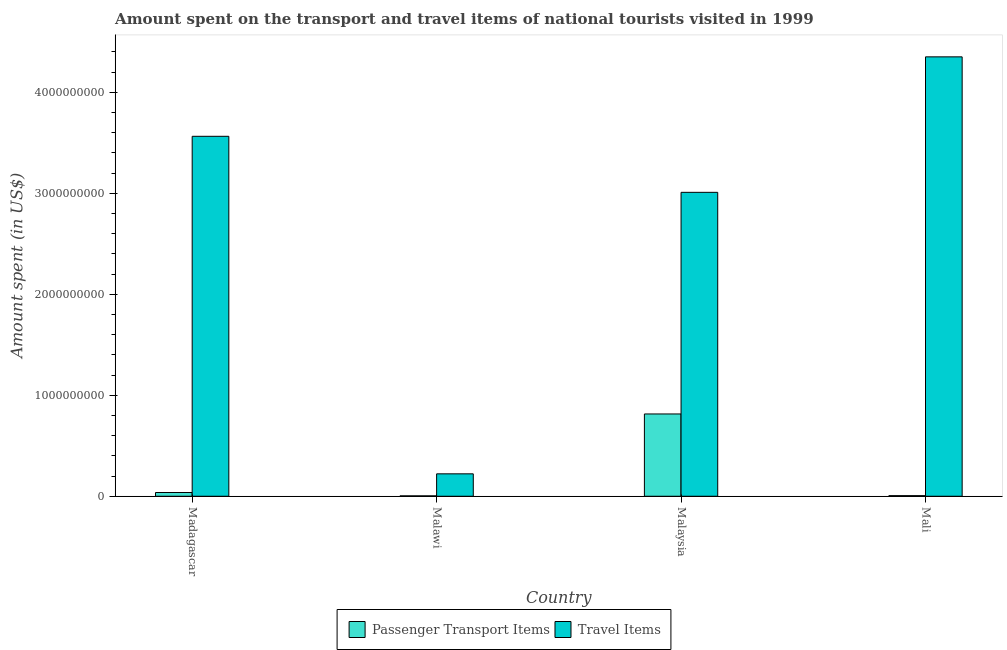How many bars are there on the 1st tick from the left?
Your response must be concise. 2. What is the label of the 4th group of bars from the left?
Keep it short and to the point. Mali. In how many cases, is the number of bars for a given country not equal to the number of legend labels?
Keep it short and to the point. 0. What is the amount spent on passenger transport items in Madagascar?
Provide a succinct answer. 3.70e+07. Across all countries, what is the maximum amount spent on passenger transport items?
Give a very brief answer. 8.15e+08. Across all countries, what is the minimum amount spent on passenger transport items?
Offer a very short reply. 4.00e+06. In which country was the amount spent on passenger transport items maximum?
Offer a very short reply. Malaysia. In which country was the amount spent in travel items minimum?
Your answer should be very brief. Malawi. What is the total amount spent on passenger transport items in the graph?
Make the answer very short. 8.62e+08. What is the difference between the amount spent on passenger transport items in Madagascar and that in Mali?
Provide a succinct answer. 3.10e+07. What is the difference between the amount spent on passenger transport items in Malaysia and the amount spent in travel items in Malawi?
Make the answer very short. 5.93e+08. What is the average amount spent on passenger transport items per country?
Keep it short and to the point. 2.16e+08. What is the difference between the amount spent on passenger transport items and amount spent in travel items in Malaysia?
Keep it short and to the point. -2.20e+09. In how many countries, is the amount spent on passenger transport items greater than 4000000000 US$?
Provide a short and direct response. 0. What is the ratio of the amount spent in travel items in Malawi to that in Malaysia?
Your response must be concise. 0.07. What is the difference between the highest and the second highest amount spent on passenger transport items?
Provide a succinct answer. 7.78e+08. What is the difference between the highest and the lowest amount spent in travel items?
Make the answer very short. 4.13e+09. What does the 2nd bar from the left in Madagascar represents?
Provide a succinct answer. Travel Items. What does the 2nd bar from the right in Malawi represents?
Provide a short and direct response. Passenger Transport Items. What is the difference between two consecutive major ticks on the Y-axis?
Offer a terse response. 1.00e+09. Where does the legend appear in the graph?
Ensure brevity in your answer.  Bottom center. What is the title of the graph?
Ensure brevity in your answer.  Amount spent on the transport and travel items of national tourists visited in 1999. What is the label or title of the Y-axis?
Ensure brevity in your answer.  Amount spent (in US$). What is the Amount spent (in US$) in Passenger Transport Items in Madagascar?
Offer a very short reply. 3.70e+07. What is the Amount spent (in US$) in Travel Items in Madagascar?
Your answer should be compact. 3.56e+09. What is the Amount spent (in US$) of Travel Items in Malawi?
Offer a very short reply. 2.22e+08. What is the Amount spent (in US$) of Passenger Transport Items in Malaysia?
Your answer should be compact. 8.15e+08. What is the Amount spent (in US$) in Travel Items in Malaysia?
Ensure brevity in your answer.  3.01e+09. What is the Amount spent (in US$) of Passenger Transport Items in Mali?
Make the answer very short. 6.00e+06. What is the Amount spent (in US$) of Travel Items in Mali?
Make the answer very short. 4.35e+09. Across all countries, what is the maximum Amount spent (in US$) of Passenger Transport Items?
Give a very brief answer. 8.15e+08. Across all countries, what is the maximum Amount spent (in US$) in Travel Items?
Ensure brevity in your answer.  4.35e+09. Across all countries, what is the minimum Amount spent (in US$) of Passenger Transport Items?
Offer a terse response. 4.00e+06. Across all countries, what is the minimum Amount spent (in US$) of Travel Items?
Offer a terse response. 2.22e+08. What is the total Amount spent (in US$) of Passenger Transport Items in the graph?
Give a very brief answer. 8.62e+08. What is the total Amount spent (in US$) in Travel Items in the graph?
Offer a terse response. 1.11e+1. What is the difference between the Amount spent (in US$) in Passenger Transport Items in Madagascar and that in Malawi?
Keep it short and to the point. 3.30e+07. What is the difference between the Amount spent (in US$) of Travel Items in Madagascar and that in Malawi?
Your response must be concise. 3.34e+09. What is the difference between the Amount spent (in US$) in Passenger Transport Items in Madagascar and that in Malaysia?
Make the answer very short. -7.78e+08. What is the difference between the Amount spent (in US$) of Travel Items in Madagascar and that in Malaysia?
Your answer should be compact. 5.55e+08. What is the difference between the Amount spent (in US$) of Passenger Transport Items in Madagascar and that in Mali?
Your answer should be compact. 3.10e+07. What is the difference between the Amount spent (in US$) of Travel Items in Madagascar and that in Mali?
Keep it short and to the point. -7.87e+08. What is the difference between the Amount spent (in US$) of Passenger Transport Items in Malawi and that in Malaysia?
Your response must be concise. -8.11e+08. What is the difference between the Amount spent (in US$) in Travel Items in Malawi and that in Malaysia?
Your answer should be compact. -2.79e+09. What is the difference between the Amount spent (in US$) in Travel Items in Malawi and that in Mali?
Make the answer very short. -4.13e+09. What is the difference between the Amount spent (in US$) of Passenger Transport Items in Malaysia and that in Mali?
Provide a succinct answer. 8.09e+08. What is the difference between the Amount spent (in US$) in Travel Items in Malaysia and that in Mali?
Give a very brief answer. -1.34e+09. What is the difference between the Amount spent (in US$) of Passenger Transport Items in Madagascar and the Amount spent (in US$) of Travel Items in Malawi?
Your answer should be compact. -1.85e+08. What is the difference between the Amount spent (in US$) in Passenger Transport Items in Madagascar and the Amount spent (in US$) in Travel Items in Malaysia?
Provide a succinct answer. -2.97e+09. What is the difference between the Amount spent (in US$) in Passenger Transport Items in Madagascar and the Amount spent (in US$) in Travel Items in Mali?
Ensure brevity in your answer.  -4.32e+09. What is the difference between the Amount spent (in US$) of Passenger Transport Items in Malawi and the Amount spent (in US$) of Travel Items in Malaysia?
Provide a succinct answer. -3.01e+09. What is the difference between the Amount spent (in US$) in Passenger Transport Items in Malawi and the Amount spent (in US$) in Travel Items in Mali?
Your answer should be very brief. -4.35e+09. What is the difference between the Amount spent (in US$) of Passenger Transport Items in Malaysia and the Amount spent (in US$) of Travel Items in Mali?
Your answer should be very brief. -3.54e+09. What is the average Amount spent (in US$) in Passenger Transport Items per country?
Your answer should be compact. 2.16e+08. What is the average Amount spent (in US$) in Travel Items per country?
Give a very brief answer. 2.79e+09. What is the difference between the Amount spent (in US$) in Passenger Transport Items and Amount spent (in US$) in Travel Items in Madagascar?
Your answer should be compact. -3.53e+09. What is the difference between the Amount spent (in US$) of Passenger Transport Items and Amount spent (in US$) of Travel Items in Malawi?
Keep it short and to the point. -2.18e+08. What is the difference between the Amount spent (in US$) in Passenger Transport Items and Amount spent (in US$) in Travel Items in Malaysia?
Provide a short and direct response. -2.20e+09. What is the difference between the Amount spent (in US$) of Passenger Transport Items and Amount spent (in US$) of Travel Items in Mali?
Your answer should be very brief. -4.35e+09. What is the ratio of the Amount spent (in US$) in Passenger Transport Items in Madagascar to that in Malawi?
Your response must be concise. 9.25. What is the ratio of the Amount spent (in US$) of Travel Items in Madagascar to that in Malawi?
Your answer should be compact. 16.06. What is the ratio of the Amount spent (in US$) in Passenger Transport Items in Madagascar to that in Malaysia?
Offer a terse response. 0.05. What is the ratio of the Amount spent (in US$) of Travel Items in Madagascar to that in Malaysia?
Ensure brevity in your answer.  1.18. What is the ratio of the Amount spent (in US$) in Passenger Transport Items in Madagascar to that in Mali?
Your response must be concise. 6.17. What is the ratio of the Amount spent (in US$) of Travel Items in Madagascar to that in Mali?
Offer a terse response. 0.82. What is the ratio of the Amount spent (in US$) of Passenger Transport Items in Malawi to that in Malaysia?
Your answer should be compact. 0. What is the ratio of the Amount spent (in US$) of Travel Items in Malawi to that in Malaysia?
Provide a succinct answer. 0.07. What is the ratio of the Amount spent (in US$) in Passenger Transport Items in Malawi to that in Mali?
Your answer should be compact. 0.67. What is the ratio of the Amount spent (in US$) of Travel Items in Malawi to that in Mali?
Offer a terse response. 0.05. What is the ratio of the Amount spent (in US$) of Passenger Transport Items in Malaysia to that in Mali?
Offer a very short reply. 135.83. What is the ratio of the Amount spent (in US$) of Travel Items in Malaysia to that in Mali?
Keep it short and to the point. 0.69. What is the difference between the highest and the second highest Amount spent (in US$) in Passenger Transport Items?
Give a very brief answer. 7.78e+08. What is the difference between the highest and the second highest Amount spent (in US$) of Travel Items?
Offer a very short reply. 7.87e+08. What is the difference between the highest and the lowest Amount spent (in US$) in Passenger Transport Items?
Make the answer very short. 8.11e+08. What is the difference between the highest and the lowest Amount spent (in US$) in Travel Items?
Your response must be concise. 4.13e+09. 